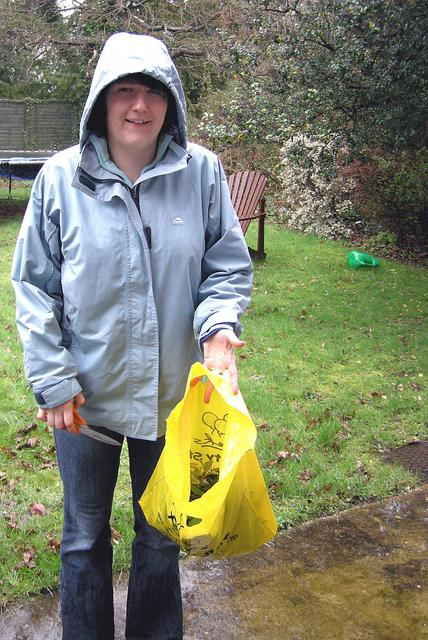What was probably stored in the container on the grass? detergent 